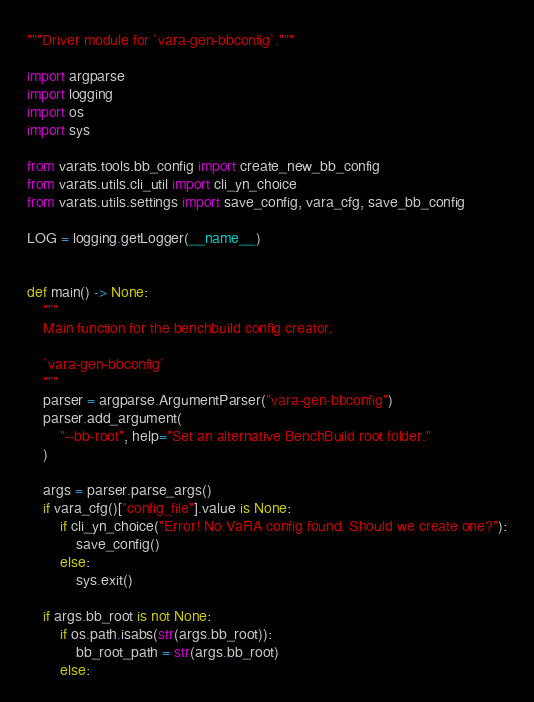<code> <loc_0><loc_0><loc_500><loc_500><_Python_>"""Driver module for `vara-gen-bbconfig`."""

import argparse
import logging
import os
import sys

from varats.tools.bb_config import create_new_bb_config
from varats.utils.cli_util import cli_yn_choice
from varats.utils.settings import save_config, vara_cfg, save_bb_config

LOG = logging.getLogger(__name__)


def main() -> None:
    """
    Main function for the benchbuild config creator.

    `vara-gen-bbconfig`
    """
    parser = argparse.ArgumentParser("vara-gen-bbconfig")
    parser.add_argument(
        "--bb-root", help="Set an alternative BenchBuild root folder."
    )

    args = parser.parse_args()
    if vara_cfg()["config_file"].value is None:
        if cli_yn_choice("Error! No VaRA config found. Should we create one?"):
            save_config()
        else:
            sys.exit()

    if args.bb_root is not None:
        if os.path.isabs(str(args.bb_root)):
            bb_root_path = str(args.bb_root)
        else:</code> 